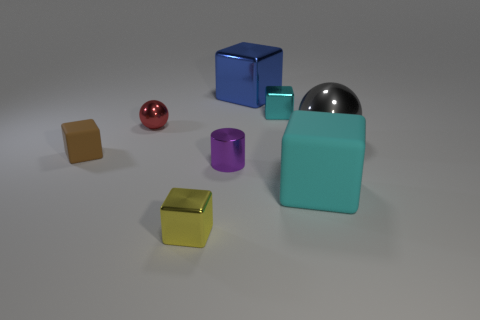What shape is the small thing that is to the left of the small yellow block and in front of the big gray metal ball?
Your response must be concise. Cube. There is a cyan object behind the metal sphere behind the big gray object; are there any large cubes that are behind it?
Make the answer very short. Yes. What number of other things are made of the same material as the small red ball?
Provide a succinct answer. 5. How many tiny metallic balls are there?
Offer a terse response. 1. How many things are either purple metal cylinders or metal cubes that are to the right of the large metallic block?
Give a very brief answer. 2. Is there anything else that is the same shape as the small purple metallic thing?
Keep it short and to the point. No. Do the thing in front of the cyan matte thing and the large blue shiny cube have the same size?
Offer a very short reply. No. How many matte objects are either brown objects or big red objects?
Ensure brevity in your answer.  1. There is a rubber cube left of the small red sphere; what size is it?
Give a very brief answer. Small. Does the tiny matte thing have the same shape as the tiny red thing?
Your answer should be compact. No. 